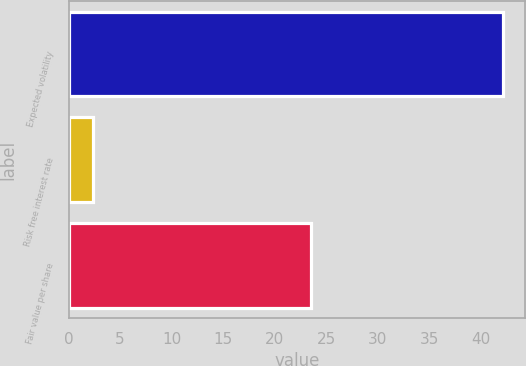<chart> <loc_0><loc_0><loc_500><loc_500><bar_chart><fcel>Expected volatility<fcel>Risk free interest rate<fcel>Fair value per share<nl><fcel>42.16<fcel>2.33<fcel>23.54<nl></chart> 